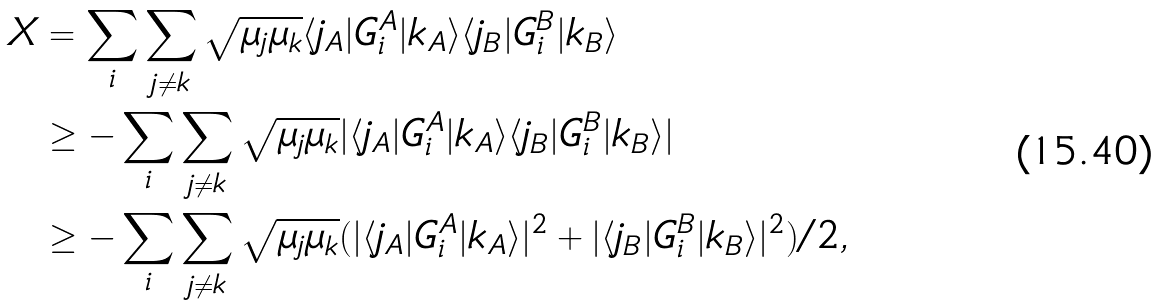Convert formula to latex. <formula><loc_0><loc_0><loc_500><loc_500>X & = \sum _ { i } \sum _ { j \neq k } \sqrt { \mu _ { j } \mu _ { k } } \langle j _ { A } | G _ { i } ^ { A } | k _ { A } \rangle \langle j _ { B } | G _ { i } ^ { B } | k _ { B } \rangle \\ & \geq - \sum _ { i } \sum _ { j \ne k } \sqrt { \mu _ { j } \mu _ { k } } | \langle j _ { A } | G _ { i } ^ { A } | k _ { A } \rangle \langle j _ { B } | G _ { i } ^ { B } | k _ { B } \rangle | \\ & \geq - \sum _ { i } \sum _ { j \ne k } \sqrt { \mu _ { j } \mu _ { k } } ( | \langle j _ { A } | G _ { i } ^ { A } | k _ { A } \rangle | ^ { 2 } + | \langle j _ { B } | G _ { i } ^ { B } | k _ { B } \rangle | ^ { 2 } ) / 2 ,</formula> 